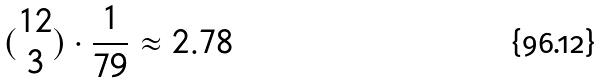<formula> <loc_0><loc_0><loc_500><loc_500>( \begin{matrix} 1 2 \\ 3 \end{matrix} ) \cdot \frac { 1 } { 7 9 } \approx 2 . 7 8</formula> 